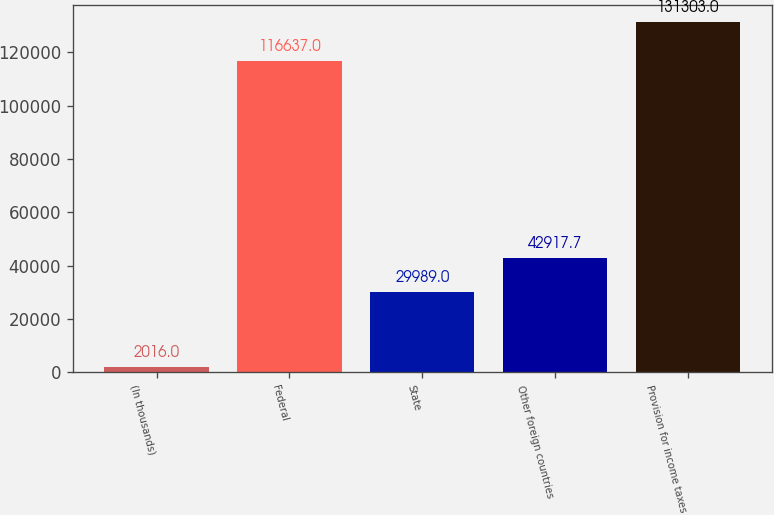<chart> <loc_0><loc_0><loc_500><loc_500><bar_chart><fcel>(In thousands)<fcel>Federal<fcel>State<fcel>Other foreign countries<fcel>Provision for income taxes<nl><fcel>2016<fcel>116637<fcel>29989<fcel>42917.7<fcel>131303<nl></chart> 